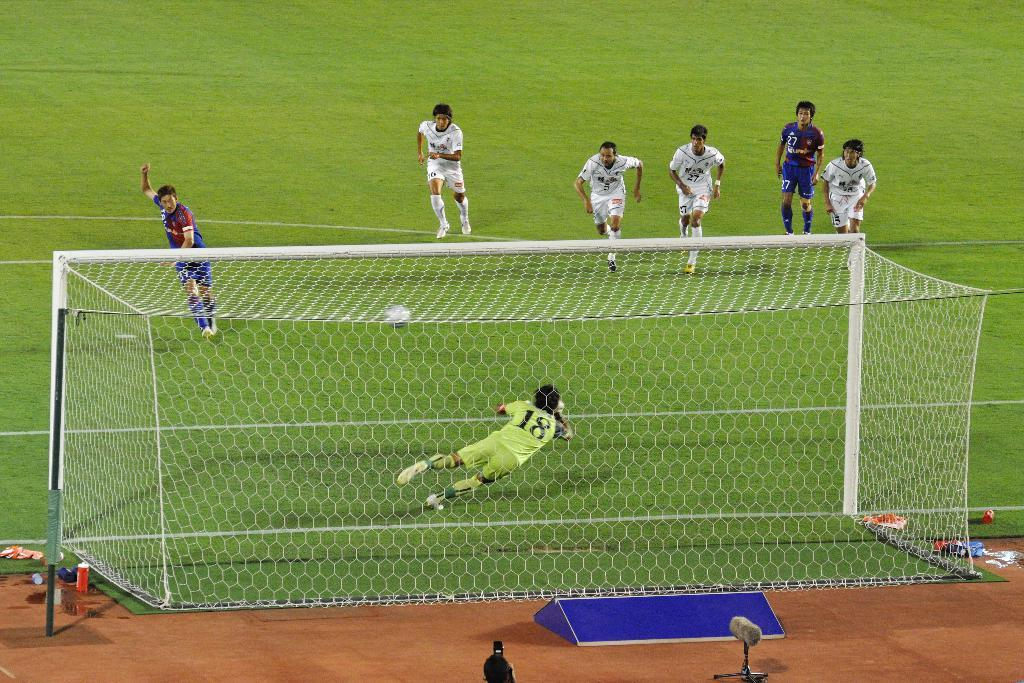Provide a one-sentence caption for the provided image. a group of soccer players with the goalie 18 attempting to block a shot. 